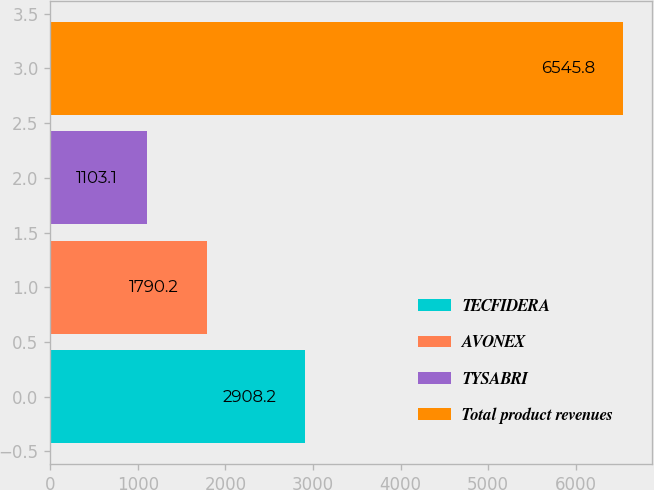Convert chart to OTSL. <chart><loc_0><loc_0><loc_500><loc_500><bar_chart><fcel>TECFIDERA<fcel>AVONEX<fcel>TYSABRI<fcel>Total product revenues<nl><fcel>2908.2<fcel>1790.2<fcel>1103.1<fcel>6545.8<nl></chart> 